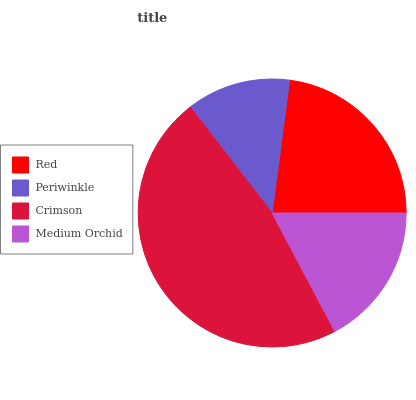Is Periwinkle the minimum?
Answer yes or no. Yes. Is Crimson the maximum?
Answer yes or no. Yes. Is Crimson the minimum?
Answer yes or no. No. Is Periwinkle the maximum?
Answer yes or no. No. Is Crimson greater than Periwinkle?
Answer yes or no. Yes. Is Periwinkle less than Crimson?
Answer yes or no. Yes. Is Periwinkle greater than Crimson?
Answer yes or no. No. Is Crimson less than Periwinkle?
Answer yes or no. No. Is Red the high median?
Answer yes or no. Yes. Is Medium Orchid the low median?
Answer yes or no. Yes. Is Medium Orchid the high median?
Answer yes or no. No. Is Periwinkle the low median?
Answer yes or no. No. 